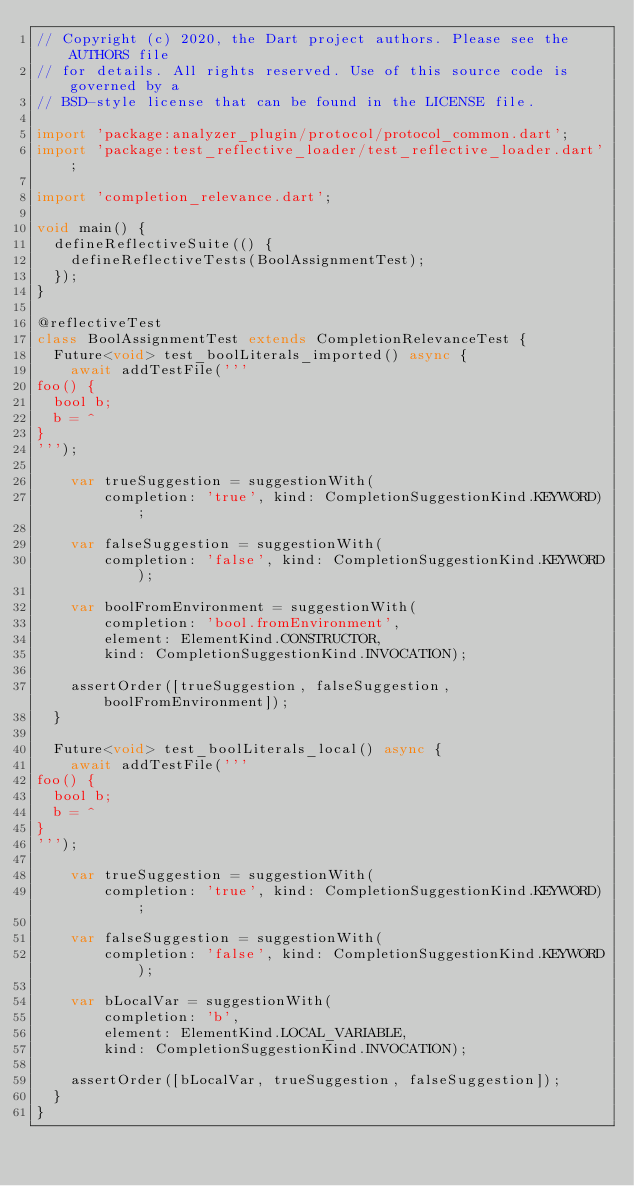Convert code to text. <code><loc_0><loc_0><loc_500><loc_500><_Dart_>// Copyright (c) 2020, the Dart project authors. Please see the AUTHORS file
// for details. All rights reserved. Use of this source code is governed by a
// BSD-style license that can be found in the LICENSE file.

import 'package:analyzer_plugin/protocol/protocol_common.dart';
import 'package:test_reflective_loader/test_reflective_loader.dart';

import 'completion_relevance.dart';

void main() {
  defineReflectiveSuite(() {
    defineReflectiveTests(BoolAssignmentTest);
  });
}

@reflectiveTest
class BoolAssignmentTest extends CompletionRelevanceTest {
  Future<void> test_boolLiterals_imported() async {
    await addTestFile('''
foo() {
  bool b;
  b = ^
}
''');

    var trueSuggestion = suggestionWith(
        completion: 'true', kind: CompletionSuggestionKind.KEYWORD);

    var falseSuggestion = suggestionWith(
        completion: 'false', kind: CompletionSuggestionKind.KEYWORD);

    var boolFromEnvironment = suggestionWith(
        completion: 'bool.fromEnvironment',
        element: ElementKind.CONSTRUCTOR,
        kind: CompletionSuggestionKind.INVOCATION);

    assertOrder([trueSuggestion, falseSuggestion, boolFromEnvironment]);
  }

  Future<void> test_boolLiterals_local() async {
    await addTestFile('''
foo() {
  bool b;
  b = ^
}
''');

    var trueSuggestion = suggestionWith(
        completion: 'true', kind: CompletionSuggestionKind.KEYWORD);

    var falseSuggestion = suggestionWith(
        completion: 'false', kind: CompletionSuggestionKind.KEYWORD);

    var bLocalVar = suggestionWith(
        completion: 'b',
        element: ElementKind.LOCAL_VARIABLE,
        kind: CompletionSuggestionKind.INVOCATION);

    assertOrder([bLocalVar, trueSuggestion, falseSuggestion]);
  }
}
</code> 